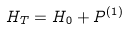<formula> <loc_0><loc_0><loc_500><loc_500>H _ { T } = H _ { 0 } + P ^ { ( 1 ) }</formula> 